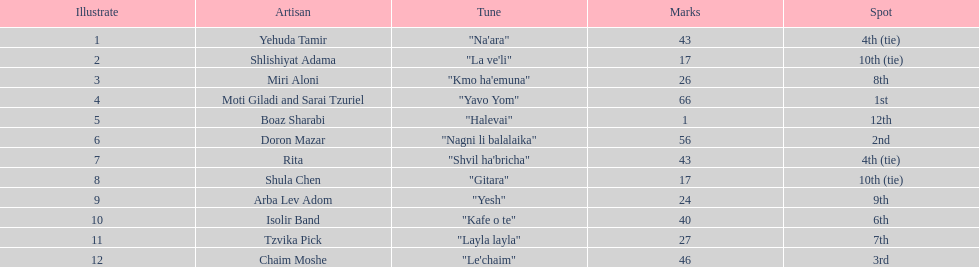Did the song "gitara" or "yesh" earn more points? "Yesh". 